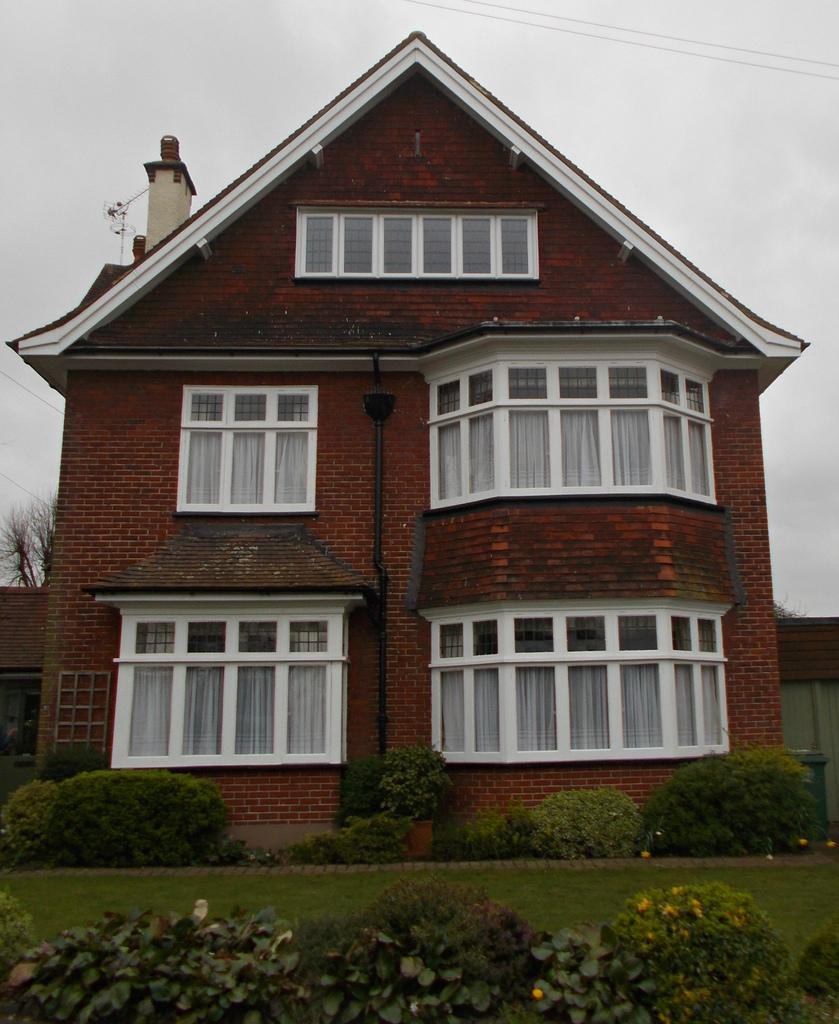What type of structure is in the image? There is a building in the image. What feature can be observed on the building? The building has glass windows. What type of vegetation is present in the image? There are trees in the image. What else can be seen in the image besides the building and trees? Wires and small plants are visible in the image. What is the color of the sky in the image? The sky appears to be white in color. How many buns are being held by the kitten in the image? There is no kitten or bun present in the image. What are the hands of the person in the image doing? There is no person present in the image. 